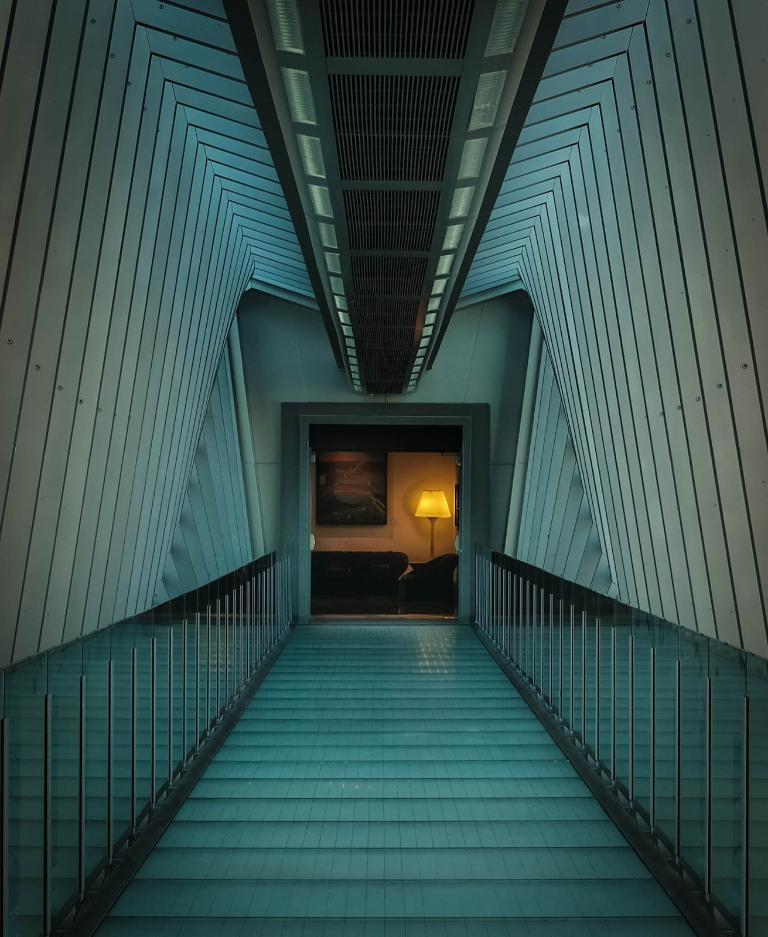What type of space is depicted in the image? The image displays the architecture of a room. What feature is present in the room that allows for entry or exit? There is a door in the room. What type of decoration can be seen on the wall in the image? There is a painting hanging on the wall. What objects are visible at the bottom of the image? Some objects are visible at the bottom of the image. Where are the lights located in the room? Lights are seen on the right side of the image. What type of stamp can be seen on the painting in the image? There is no stamp visible on the painting in the image. What type of lead material is used in the construction of the room? The image does not provide information about the materials used in the construction of the room. 